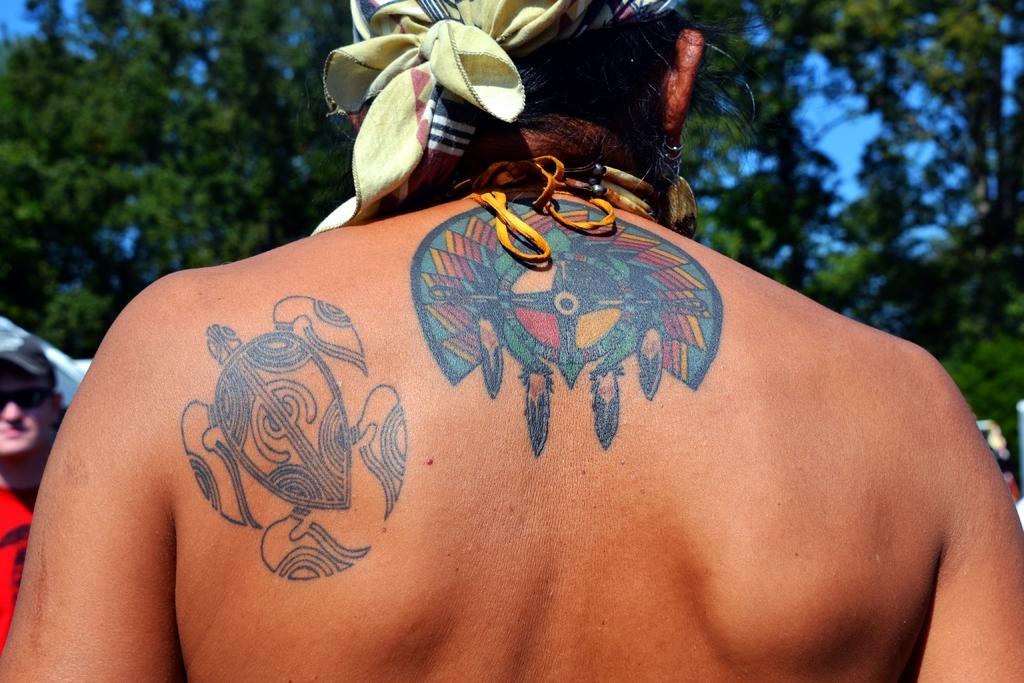In one or two sentences, can you explain what this image depicts? The person in front of the picture has tattoos on his or her back. We see a yellow color cloth is tied to his or her hair. On the left side, the man in red T-shirt who is wearing goggles and a cap is standing. In the background, there are trees. 